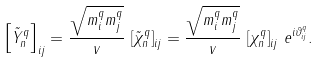Convert formula to latex. <formula><loc_0><loc_0><loc_500><loc_500>\left [ \tilde { Y } _ { n } ^ { q } \right ] _ { i j } = \frac { \sqrt { m ^ { q } _ { i } m ^ { q } _ { j } } } { v } \, \left [ \tilde { \chi } _ { n } ^ { q } \right ] _ { i j } = \frac { \sqrt { m ^ { q } _ { i } m ^ { q } _ { j } } } { v } \, \left [ \chi _ { n } ^ { q } \right ] _ { i j } \, e ^ { i \vartheta ^ { q } _ { i j } } .</formula> 